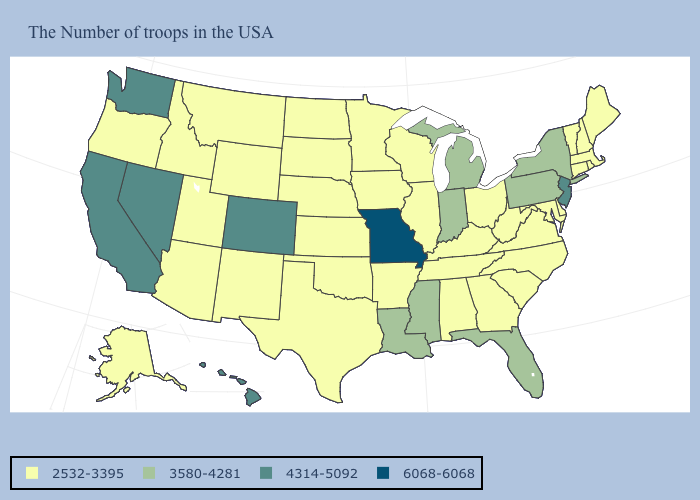What is the value of New York?
Quick response, please. 3580-4281. What is the value of Rhode Island?
Give a very brief answer. 2532-3395. Does New Jersey have the same value as California?
Answer briefly. Yes. What is the highest value in the USA?
Short answer required. 6068-6068. Name the states that have a value in the range 2532-3395?
Answer briefly. Maine, Massachusetts, Rhode Island, New Hampshire, Vermont, Connecticut, Delaware, Maryland, Virginia, North Carolina, South Carolina, West Virginia, Ohio, Georgia, Kentucky, Alabama, Tennessee, Wisconsin, Illinois, Arkansas, Minnesota, Iowa, Kansas, Nebraska, Oklahoma, Texas, South Dakota, North Dakota, Wyoming, New Mexico, Utah, Montana, Arizona, Idaho, Oregon, Alaska. Does New Jersey have the highest value in the Northeast?
Write a very short answer. Yes. Which states hav the highest value in the South?
Concise answer only. Florida, Mississippi, Louisiana. What is the value of California?
Short answer required. 4314-5092. Name the states that have a value in the range 4314-5092?
Write a very short answer. New Jersey, Colorado, Nevada, California, Washington, Hawaii. What is the highest value in the Northeast ?
Answer briefly. 4314-5092. Does North Carolina have the same value as Washington?
Keep it brief. No. Name the states that have a value in the range 4314-5092?
Give a very brief answer. New Jersey, Colorado, Nevada, California, Washington, Hawaii. What is the value of Pennsylvania?
Concise answer only. 3580-4281. Which states have the lowest value in the USA?
Keep it brief. Maine, Massachusetts, Rhode Island, New Hampshire, Vermont, Connecticut, Delaware, Maryland, Virginia, North Carolina, South Carolina, West Virginia, Ohio, Georgia, Kentucky, Alabama, Tennessee, Wisconsin, Illinois, Arkansas, Minnesota, Iowa, Kansas, Nebraska, Oklahoma, Texas, South Dakota, North Dakota, Wyoming, New Mexico, Utah, Montana, Arizona, Idaho, Oregon, Alaska. 